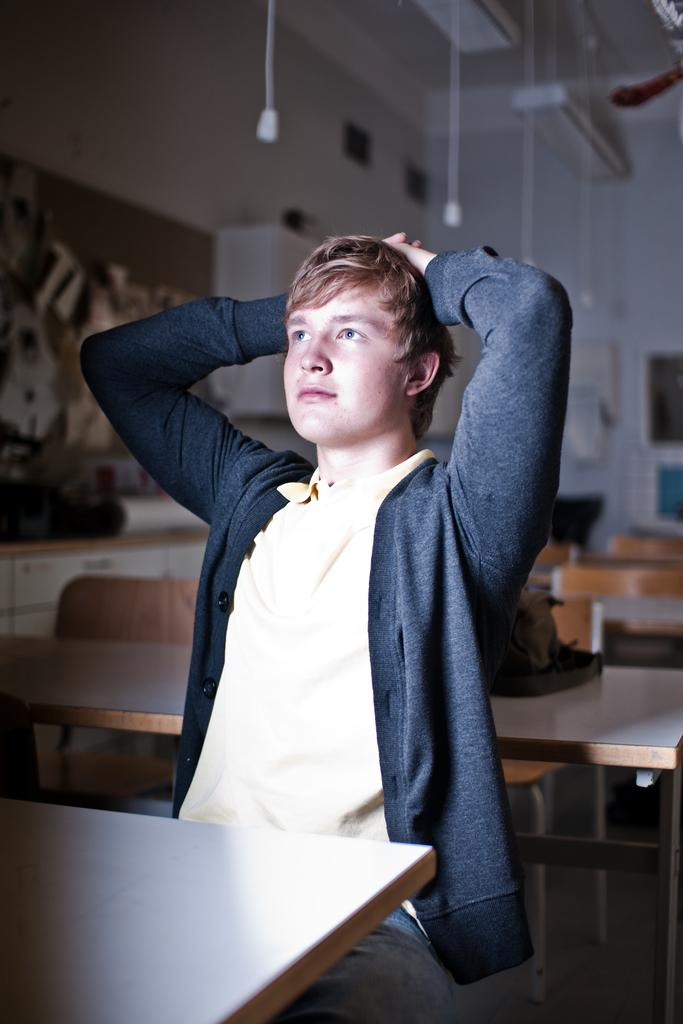Who is present in the image? There is a man in the image. What is the man wearing? The man is wearing a blue jacket. What is the man doing in the image? The man is sitting on a chair. What can be seen in the background of the image? There are multiple chairs and tables in the background of the image. What type of insect is crawling on the man's jacket in the image? There is no insect visible on the man's jacket in the image. What type of lamp is on the table in the image? There is no lamp present in the image; only chairs and tables are visible in the background. 